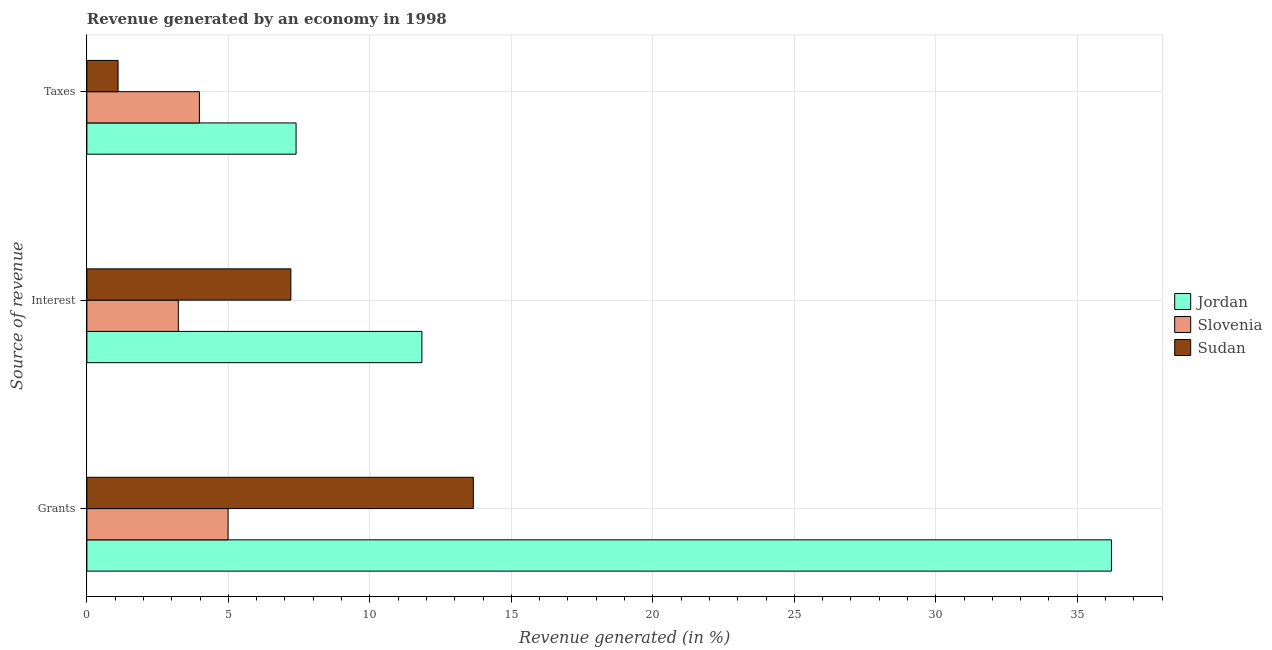How many different coloured bars are there?
Provide a succinct answer. 3. How many groups of bars are there?
Provide a succinct answer. 3. Are the number of bars per tick equal to the number of legend labels?
Provide a short and direct response. Yes. Are the number of bars on each tick of the Y-axis equal?
Provide a short and direct response. Yes. How many bars are there on the 1st tick from the bottom?
Provide a succinct answer. 3. What is the label of the 1st group of bars from the top?
Provide a short and direct response. Taxes. What is the percentage of revenue generated by interest in Sudan?
Provide a short and direct response. 7.21. Across all countries, what is the maximum percentage of revenue generated by grants?
Make the answer very short. 36.21. Across all countries, what is the minimum percentage of revenue generated by taxes?
Provide a short and direct response. 1.1. In which country was the percentage of revenue generated by grants maximum?
Ensure brevity in your answer.  Jordan. In which country was the percentage of revenue generated by interest minimum?
Provide a short and direct response. Slovenia. What is the total percentage of revenue generated by grants in the graph?
Keep it short and to the point. 54.86. What is the difference between the percentage of revenue generated by grants in Sudan and that in Jordan?
Give a very brief answer. -22.55. What is the difference between the percentage of revenue generated by taxes in Sudan and the percentage of revenue generated by grants in Slovenia?
Give a very brief answer. -3.89. What is the average percentage of revenue generated by grants per country?
Provide a succinct answer. 18.29. What is the difference between the percentage of revenue generated by grants and percentage of revenue generated by interest in Jordan?
Give a very brief answer. 24.37. What is the ratio of the percentage of revenue generated by taxes in Sudan to that in Jordan?
Ensure brevity in your answer.  0.15. Is the percentage of revenue generated by interest in Jordan less than that in Slovenia?
Provide a succinct answer. No. What is the difference between the highest and the second highest percentage of revenue generated by grants?
Make the answer very short. 22.55. What is the difference between the highest and the lowest percentage of revenue generated by interest?
Make the answer very short. 8.61. What does the 2nd bar from the top in Grants represents?
Your answer should be very brief. Slovenia. What does the 2nd bar from the bottom in Grants represents?
Offer a very short reply. Slovenia. How many bars are there?
Keep it short and to the point. 9. Are all the bars in the graph horizontal?
Offer a terse response. Yes. How many countries are there in the graph?
Offer a terse response. 3. What is the difference between two consecutive major ticks on the X-axis?
Give a very brief answer. 5. Are the values on the major ticks of X-axis written in scientific E-notation?
Offer a terse response. No. Does the graph contain any zero values?
Offer a terse response. No. Does the graph contain grids?
Offer a terse response. Yes. How are the legend labels stacked?
Your answer should be compact. Vertical. What is the title of the graph?
Ensure brevity in your answer.  Revenue generated by an economy in 1998. What is the label or title of the X-axis?
Ensure brevity in your answer.  Revenue generated (in %). What is the label or title of the Y-axis?
Make the answer very short. Source of revenue. What is the Revenue generated (in %) in Jordan in Grants?
Offer a very short reply. 36.21. What is the Revenue generated (in %) of Slovenia in Grants?
Offer a terse response. 4.99. What is the Revenue generated (in %) of Sudan in Grants?
Keep it short and to the point. 13.66. What is the Revenue generated (in %) of Jordan in Interest?
Your response must be concise. 11.84. What is the Revenue generated (in %) of Slovenia in Interest?
Your response must be concise. 3.23. What is the Revenue generated (in %) of Sudan in Interest?
Make the answer very short. 7.21. What is the Revenue generated (in %) of Jordan in Taxes?
Make the answer very short. 7.39. What is the Revenue generated (in %) in Slovenia in Taxes?
Offer a terse response. 3.98. What is the Revenue generated (in %) in Sudan in Taxes?
Keep it short and to the point. 1.1. Across all Source of revenue, what is the maximum Revenue generated (in %) of Jordan?
Offer a terse response. 36.21. Across all Source of revenue, what is the maximum Revenue generated (in %) of Slovenia?
Keep it short and to the point. 4.99. Across all Source of revenue, what is the maximum Revenue generated (in %) in Sudan?
Give a very brief answer. 13.66. Across all Source of revenue, what is the minimum Revenue generated (in %) in Jordan?
Ensure brevity in your answer.  7.39. Across all Source of revenue, what is the minimum Revenue generated (in %) in Slovenia?
Offer a terse response. 3.23. Across all Source of revenue, what is the minimum Revenue generated (in %) of Sudan?
Your response must be concise. 1.1. What is the total Revenue generated (in %) of Jordan in the graph?
Keep it short and to the point. 55.44. What is the total Revenue generated (in %) in Slovenia in the graph?
Ensure brevity in your answer.  12.2. What is the total Revenue generated (in %) in Sudan in the graph?
Keep it short and to the point. 21.97. What is the difference between the Revenue generated (in %) in Jordan in Grants and that in Interest?
Your answer should be compact. 24.37. What is the difference between the Revenue generated (in %) in Slovenia in Grants and that in Interest?
Offer a terse response. 1.76. What is the difference between the Revenue generated (in %) of Sudan in Grants and that in Interest?
Ensure brevity in your answer.  6.45. What is the difference between the Revenue generated (in %) in Jordan in Grants and that in Taxes?
Your answer should be very brief. 28.82. What is the difference between the Revenue generated (in %) of Slovenia in Grants and that in Taxes?
Keep it short and to the point. 1.01. What is the difference between the Revenue generated (in %) in Sudan in Grants and that in Taxes?
Make the answer very short. 12.55. What is the difference between the Revenue generated (in %) in Jordan in Interest and that in Taxes?
Give a very brief answer. 4.45. What is the difference between the Revenue generated (in %) in Slovenia in Interest and that in Taxes?
Provide a succinct answer. -0.75. What is the difference between the Revenue generated (in %) of Sudan in Interest and that in Taxes?
Provide a succinct answer. 6.11. What is the difference between the Revenue generated (in %) of Jordan in Grants and the Revenue generated (in %) of Slovenia in Interest?
Ensure brevity in your answer.  32.98. What is the difference between the Revenue generated (in %) in Jordan in Grants and the Revenue generated (in %) in Sudan in Interest?
Provide a succinct answer. 29. What is the difference between the Revenue generated (in %) in Slovenia in Grants and the Revenue generated (in %) in Sudan in Interest?
Make the answer very short. -2.22. What is the difference between the Revenue generated (in %) in Jordan in Grants and the Revenue generated (in %) in Slovenia in Taxes?
Ensure brevity in your answer.  32.23. What is the difference between the Revenue generated (in %) of Jordan in Grants and the Revenue generated (in %) of Sudan in Taxes?
Offer a terse response. 35.11. What is the difference between the Revenue generated (in %) in Slovenia in Grants and the Revenue generated (in %) in Sudan in Taxes?
Make the answer very short. 3.89. What is the difference between the Revenue generated (in %) in Jordan in Interest and the Revenue generated (in %) in Slovenia in Taxes?
Ensure brevity in your answer.  7.86. What is the difference between the Revenue generated (in %) in Jordan in Interest and the Revenue generated (in %) in Sudan in Taxes?
Keep it short and to the point. 10.74. What is the difference between the Revenue generated (in %) of Slovenia in Interest and the Revenue generated (in %) of Sudan in Taxes?
Offer a terse response. 2.13. What is the average Revenue generated (in %) of Jordan per Source of revenue?
Provide a short and direct response. 18.48. What is the average Revenue generated (in %) of Slovenia per Source of revenue?
Keep it short and to the point. 4.07. What is the average Revenue generated (in %) in Sudan per Source of revenue?
Your answer should be compact. 7.32. What is the difference between the Revenue generated (in %) of Jordan and Revenue generated (in %) of Slovenia in Grants?
Your response must be concise. 31.22. What is the difference between the Revenue generated (in %) in Jordan and Revenue generated (in %) in Sudan in Grants?
Offer a terse response. 22.55. What is the difference between the Revenue generated (in %) in Slovenia and Revenue generated (in %) in Sudan in Grants?
Ensure brevity in your answer.  -8.67. What is the difference between the Revenue generated (in %) in Jordan and Revenue generated (in %) in Slovenia in Interest?
Your answer should be very brief. 8.61. What is the difference between the Revenue generated (in %) in Jordan and Revenue generated (in %) in Sudan in Interest?
Offer a very short reply. 4.63. What is the difference between the Revenue generated (in %) of Slovenia and Revenue generated (in %) of Sudan in Interest?
Provide a succinct answer. -3.98. What is the difference between the Revenue generated (in %) of Jordan and Revenue generated (in %) of Slovenia in Taxes?
Keep it short and to the point. 3.42. What is the difference between the Revenue generated (in %) of Jordan and Revenue generated (in %) of Sudan in Taxes?
Make the answer very short. 6.29. What is the difference between the Revenue generated (in %) of Slovenia and Revenue generated (in %) of Sudan in Taxes?
Make the answer very short. 2.87. What is the ratio of the Revenue generated (in %) of Jordan in Grants to that in Interest?
Ensure brevity in your answer.  3.06. What is the ratio of the Revenue generated (in %) of Slovenia in Grants to that in Interest?
Offer a very short reply. 1.54. What is the ratio of the Revenue generated (in %) of Sudan in Grants to that in Interest?
Provide a succinct answer. 1.89. What is the ratio of the Revenue generated (in %) of Jordan in Grants to that in Taxes?
Your answer should be compact. 4.9. What is the ratio of the Revenue generated (in %) in Slovenia in Grants to that in Taxes?
Provide a succinct answer. 1.25. What is the ratio of the Revenue generated (in %) of Sudan in Grants to that in Taxes?
Make the answer very short. 12.39. What is the ratio of the Revenue generated (in %) of Jordan in Interest to that in Taxes?
Your answer should be very brief. 1.6. What is the ratio of the Revenue generated (in %) of Slovenia in Interest to that in Taxes?
Your answer should be very brief. 0.81. What is the ratio of the Revenue generated (in %) in Sudan in Interest to that in Taxes?
Provide a succinct answer. 6.54. What is the difference between the highest and the second highest Revenue generated (in %) of Jordan?
Your response must be concise. 24.37. What is the difference between the highest and the second highest Revenue generated (in %) of Slovenia?
Your response must be concise. 1.01. What is the difference between the highest and the second highest Revenue generated (in %) in Sudan?
Your answer should be very brief. 6.45. What is the difference between the highest and the lowest Revenue generated (in %) in Jordan?
Offer a terse response. 28.82. What is the difference between the highest and the lowest Revenue generated (in %) in Slovenia?
Offer a very short reply. 1.76. What is the difference between the highest and the lowest Revenue generated (in %) of Sudan?
Offer a very short reply. 12.55. 